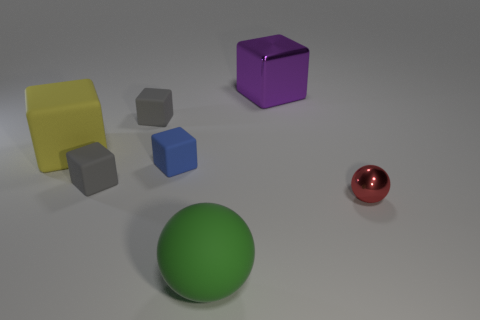Can you tell me the colors and shapes of the objects present on the left side of the purple cube? On the left side of the purple cube, there's a large yellow cube and two smaller cubes, one is gray and the other is blue. 